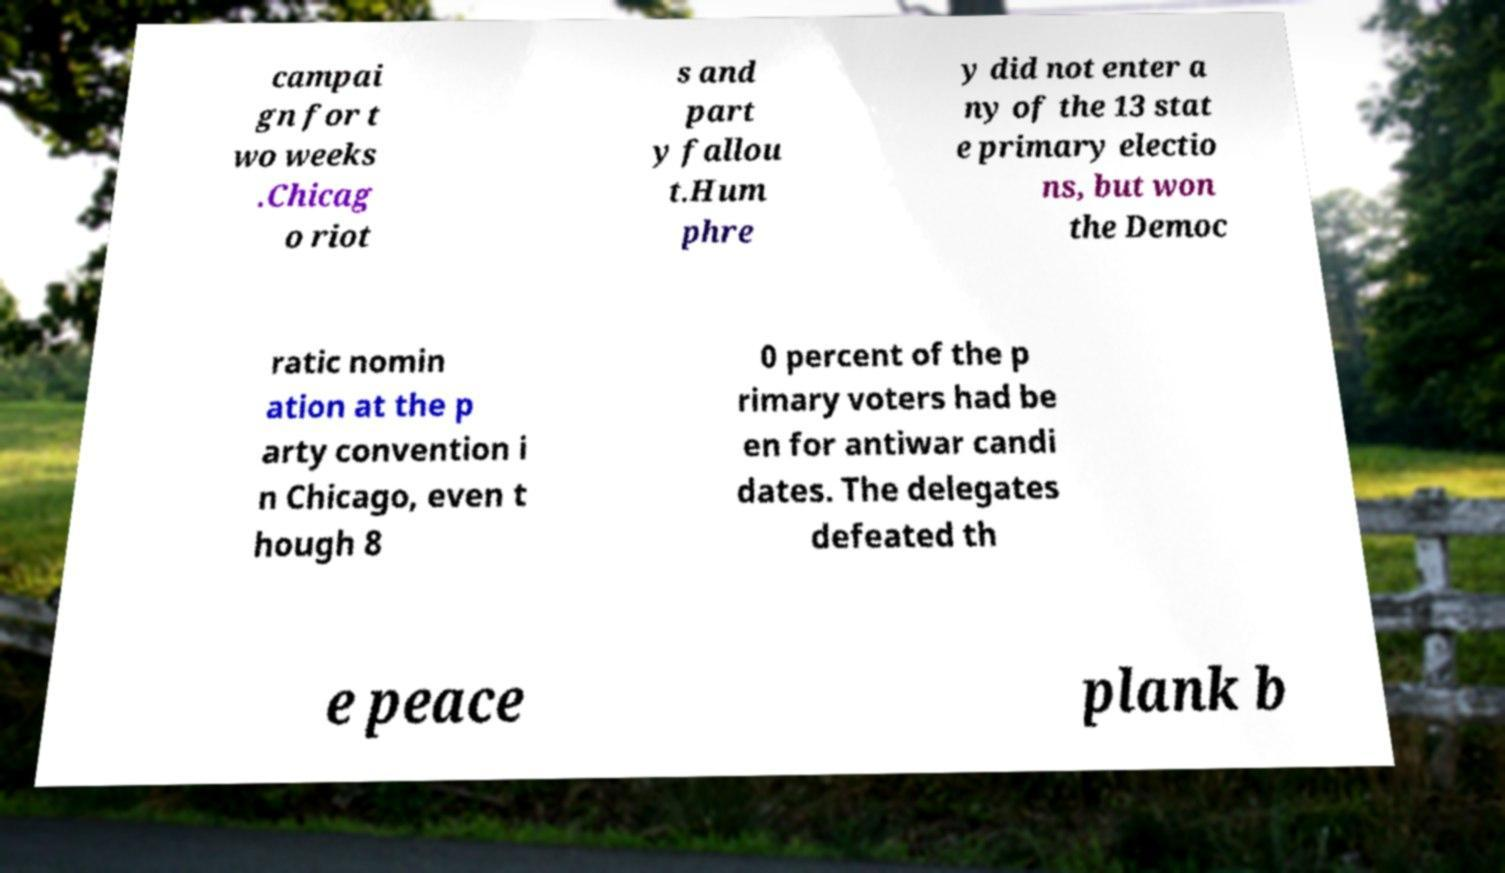For documentation purposes, I need the text within this image transcribed. Could you provide that? campai gn for t wo weeks .Chicag o riot s and part y fallou t.Hum phre y did not enter a ny of the 13 stat e primary electio ns, but won the Democ ratic nomin ation at the p arty convention i n Chicago, even t hough 8 0 percent of the p rimary voters had be en for antiwar candi dates. The delegates defeated th e peace plank b 